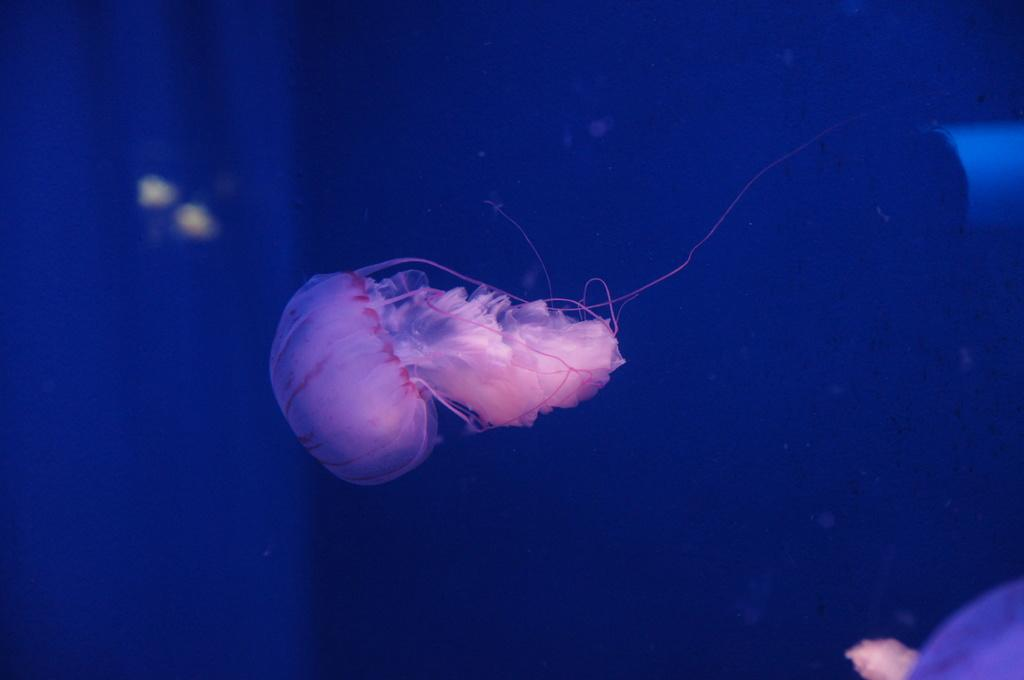What is located on the left side of the image? There is a jellyfish in the water on the left side of the image. What can be seen on the bottom right of the image? There is an object on the bottom right of the image. How would you describe the background of the image? The background of the image is blurred, and the background color is blue. What type of sidewalk can be seen in the image? There is no sidewalk present in the image; it features a jellyfish in the water and a blurred blue background. How does the liquid in the image react to the earthquake? There is no earthquake present in the image, and therefore no reaction can be observed. 